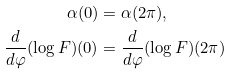Convert formula to latex. <formula><loc_0><loc_0><loc_500><loc_500>\alpha ( 0 ) & = \alpha ( 2 \pi ) , \\ \frac { d } { d \varphi } ( \log F ) ( 0 ) & = \frac { d } { d \varphi } ( \log F ) ( 2 \pi )</formula> 